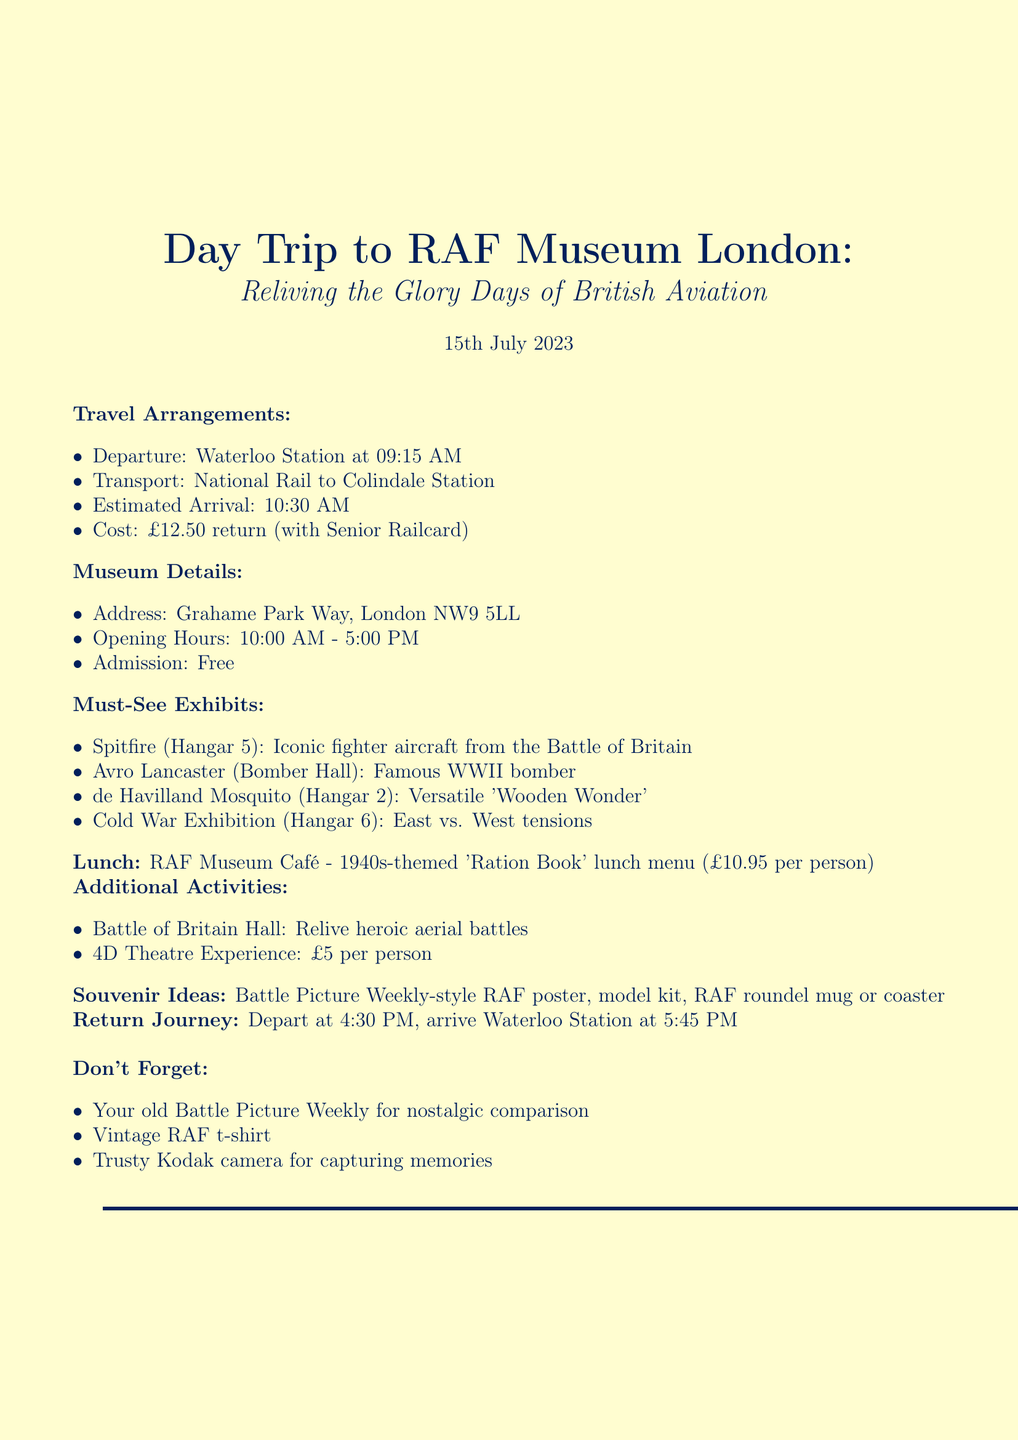What is the date of the trip? The date of the trip is clearly stated at the beginning of the memo.
Answer: 15th July 2023 Where will the group depart from? The memo specifies the departure location for the trip under travel arrangements.
Answer: Waterloo Station What is the cost of the return ticket? The ticket cost is listed in the travel arrangements section of the memo.
Answer: £12.50 return (with Senior Railcard) Which exhibition features the iconic fighter aircraft from the Battle of Britain? The specific must-see exhibit and its description indicate its location.
Answer: Hangar 5 What is one of the lunch options available? The lunch plan section describes the meal offering at the museum café.
Answer: 1940s-themed 'Ration Book' lunch menu What time does the museum open? The opening hours for the museum are mentioned in the museum details section.
Answer: 10:00 AM How much does the 4D Theatre Experience cost? The additional activities section mentions the cost for the 4D experience.
Answer: £5 per person What should attendees bring for nostalgic comparison? The additional notes section provides reminders for attendees.
Answer: old Battle Picture Weekly What souvenir idea involves a model kit? The souvenir ideas section lists items people could purchase as mementos from the trip.
Answer: model kit of Spitfire or Lancaster 